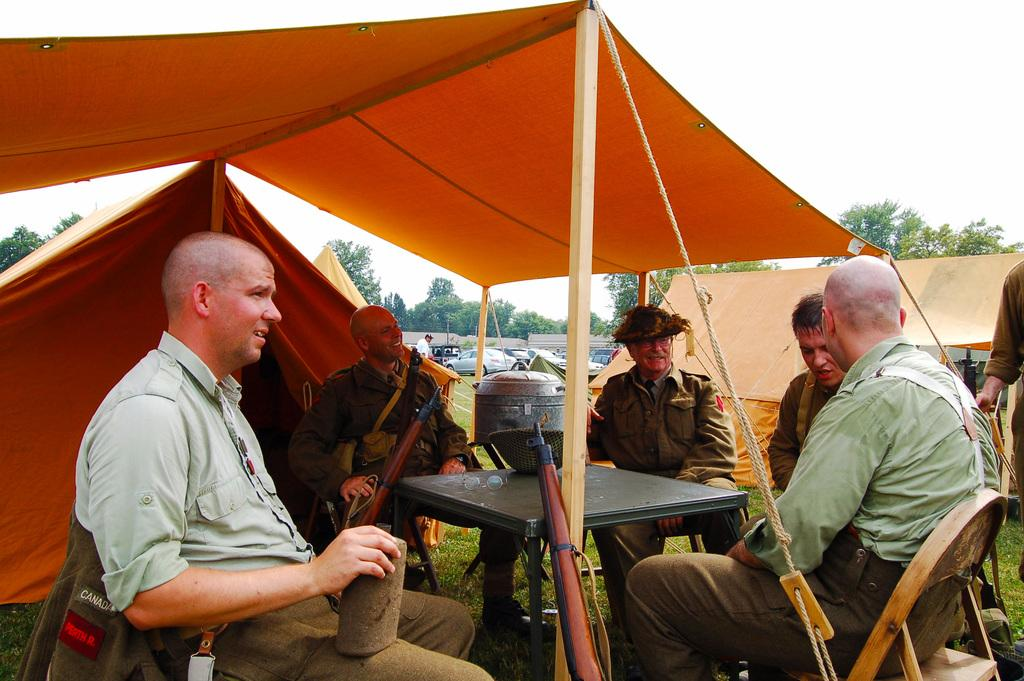What are the people in the image doing? The persons in the image are sitting on chairs. What is the main object on which they are sitting? There is a table in the image. What type of structures can be seen in the image? There are tents in the image. What type of terrain is visible in the image? Grass is visible in the image. What type of transportation is present in the image? Vehicles are present in the image. What type of natural environment is visible in the image? Trees are present in the image. What is visible in the background of the image? The sky is visible in the background of the image. Where is the mailbox located in the image? There is no mailbox present in the image. What type of yam is being used as a decoration in the image? There is no yam present in the image. 